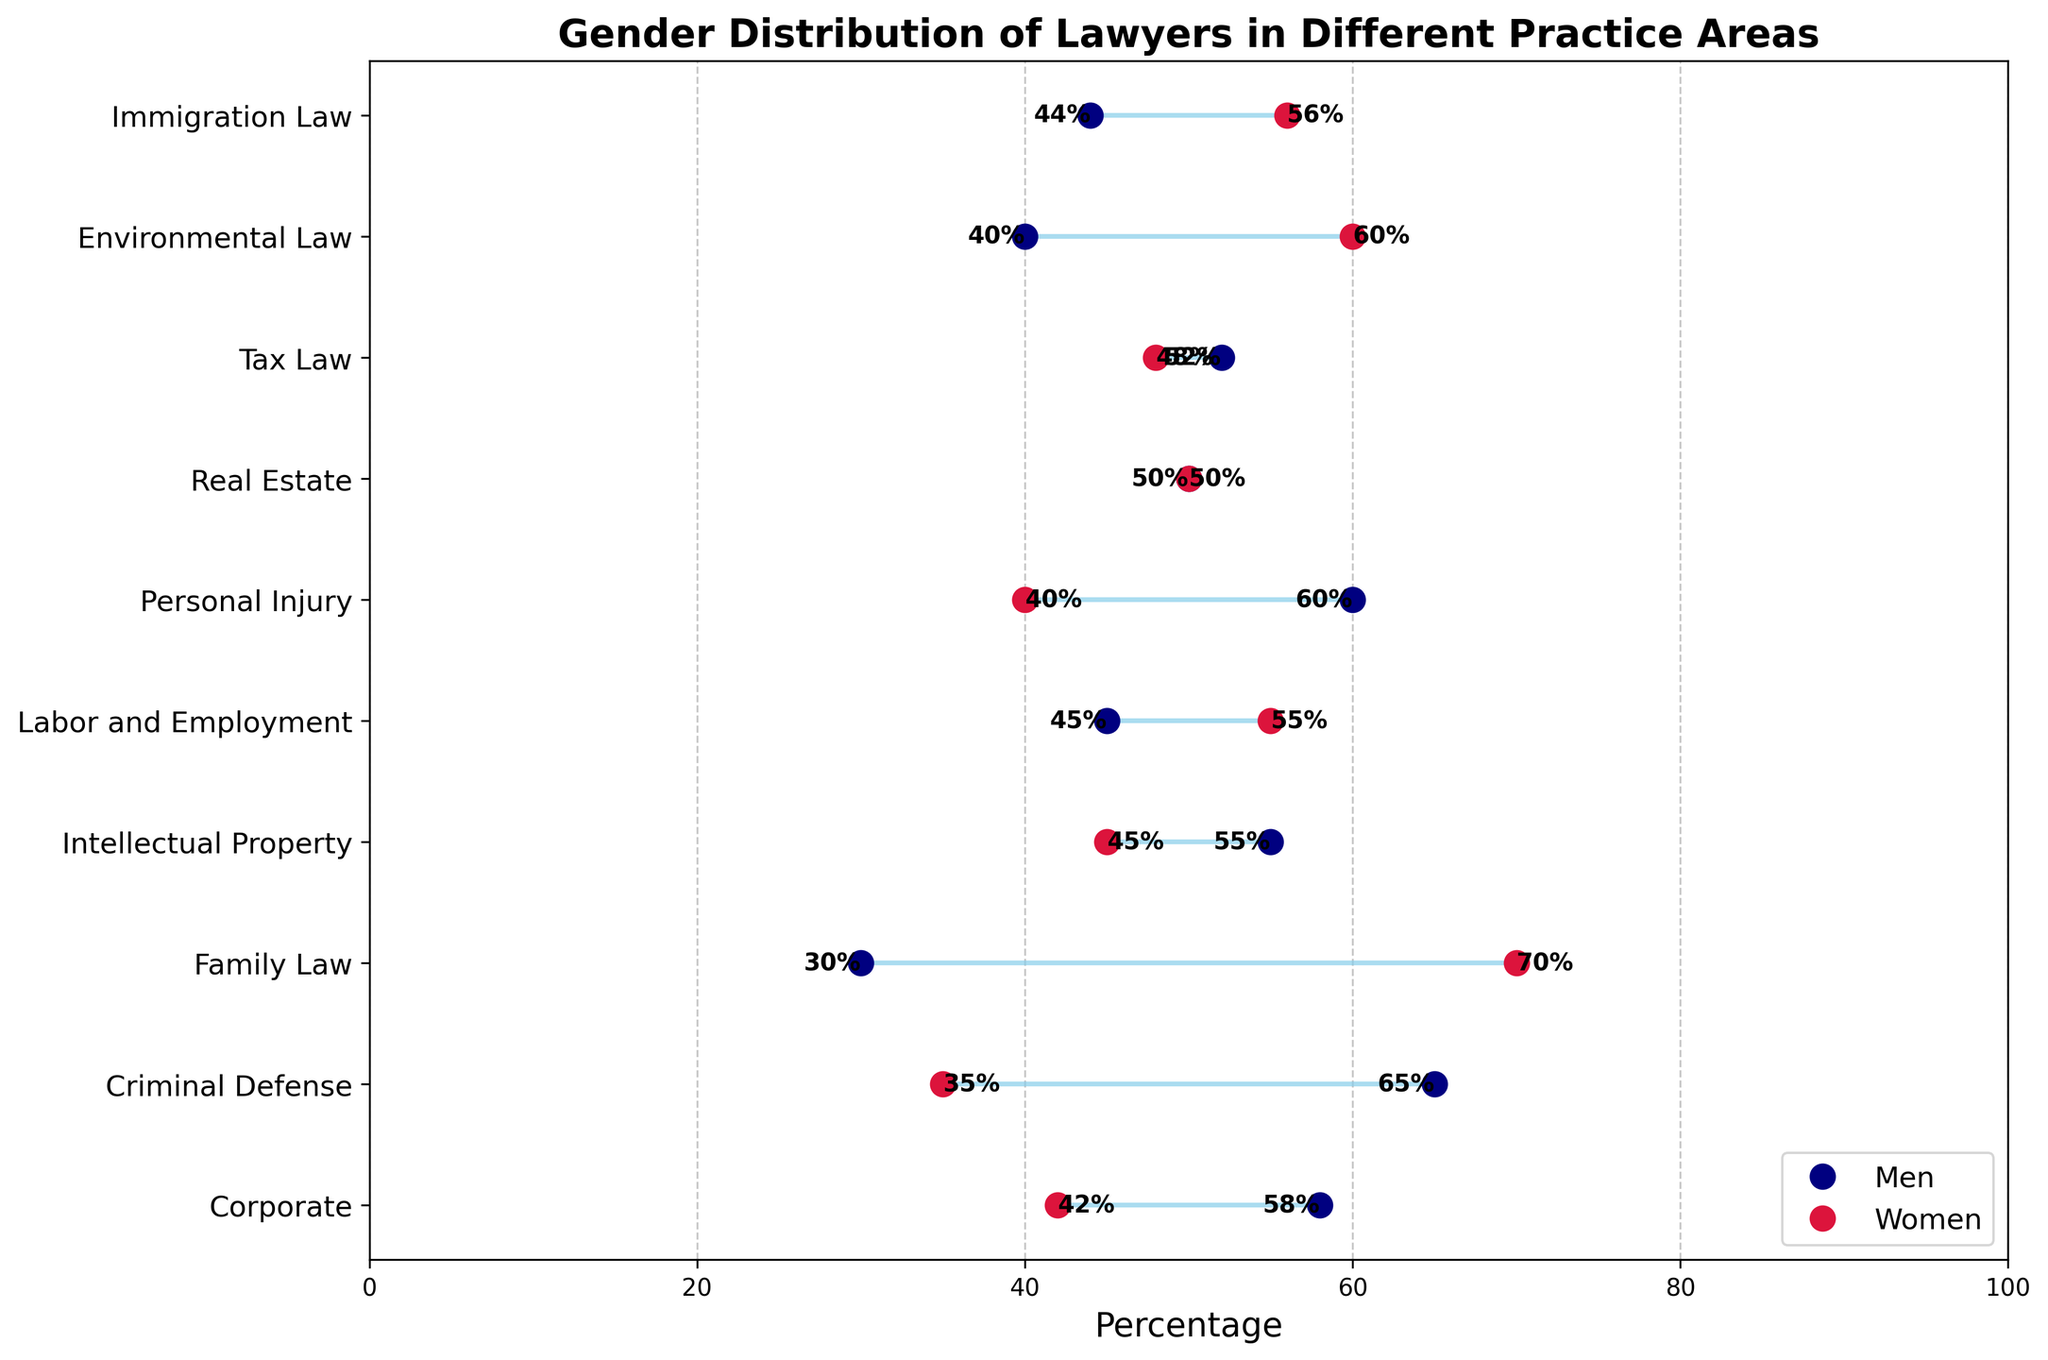What is the title of the plot? The title is usually at the top of the figure and gives a brief description of what the plot represents.
Answer: Gender Distribution of Lawyers in Different Practice Areas How many practice areas are represented in the plot? Count the number of distinct practice areas listed on the y-axis of the plot.
Answer: 10 Which practice area has the highest percentage of women lawyers? Identify the practice area corresponding to the maximum value on the percentage scale for women. Family Law has a value of 70%, which is the highest among all practice areas.
Answer: Family Law Which practice area has an equal gender distribution? Look for the practice area where the percentages for men and women are the same. Real Estate has men and women percentages both at 50%.
Answer: Real Estate What is the percentage of men in Criminal Defense? Find the percentage value corresponding to men in the Criminal Defense category.
Answer: 65% In which practice area is the percentage difference between men and women the smallest? Calculate the absolute differences between the percentages of men and women for each practice area and find the smallest difference. Real Estate has a difference of 0% (50% men, 50% women), which is the smallest among all.
Answer: Real Estate How does the percentage of women in Corporate compare to the percentage of men in Labor and Employment? Which is higher? Identify the percentages and compare them. Women in Corporate have 42%, and men in Labor and Employment have 45%. 45% is higher than 42%.
Answer: Men in Labor and Employment What is the average percentage of men across all practice areas? Add up the percentages of men in all practice areas and divide by the number of practice areas. (58 + 65 + 30 + 55 + 45 + 60 + 50 + 52 + 40 + 44) / 10 = 49.9%
Answer: 49.9% Which practice area has the highest percentage of men? Identify the practice area corresponding to the maximum value on the percentage scale for men. Criminal Defense has a value of 65%, which is the highest among all practice areas.
Answer: Criminal Defense How much higher is the percentage of women in Family Law compared to men? Subtract the percentage of men from the percentage of women in Family Law. 70% (women) - 30% (men) = 40%.
Answer: 40% 